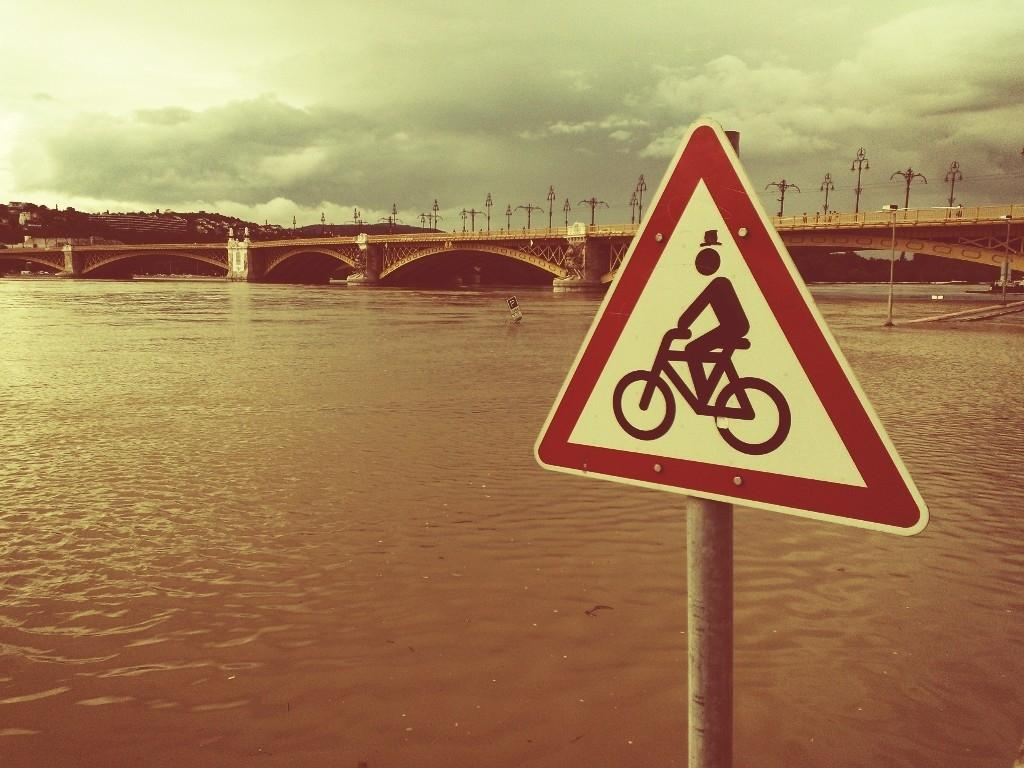What natural feature can be seen in the image? There is a river in the image. What structure is present across the river? There is a bridge across the river. What can be seen in the background of the image? The sky is visible in the background of the image. What object is present near the river? There is a pole in the image. What is attached to the pole? There is a signboard attached to the pole. What type of bells can be heard ringing near the river in the image? There are no bells present or audible in the image. Is there a cook preparing food near the river in the image? There is no cook or any indication of food preparation in the image. 